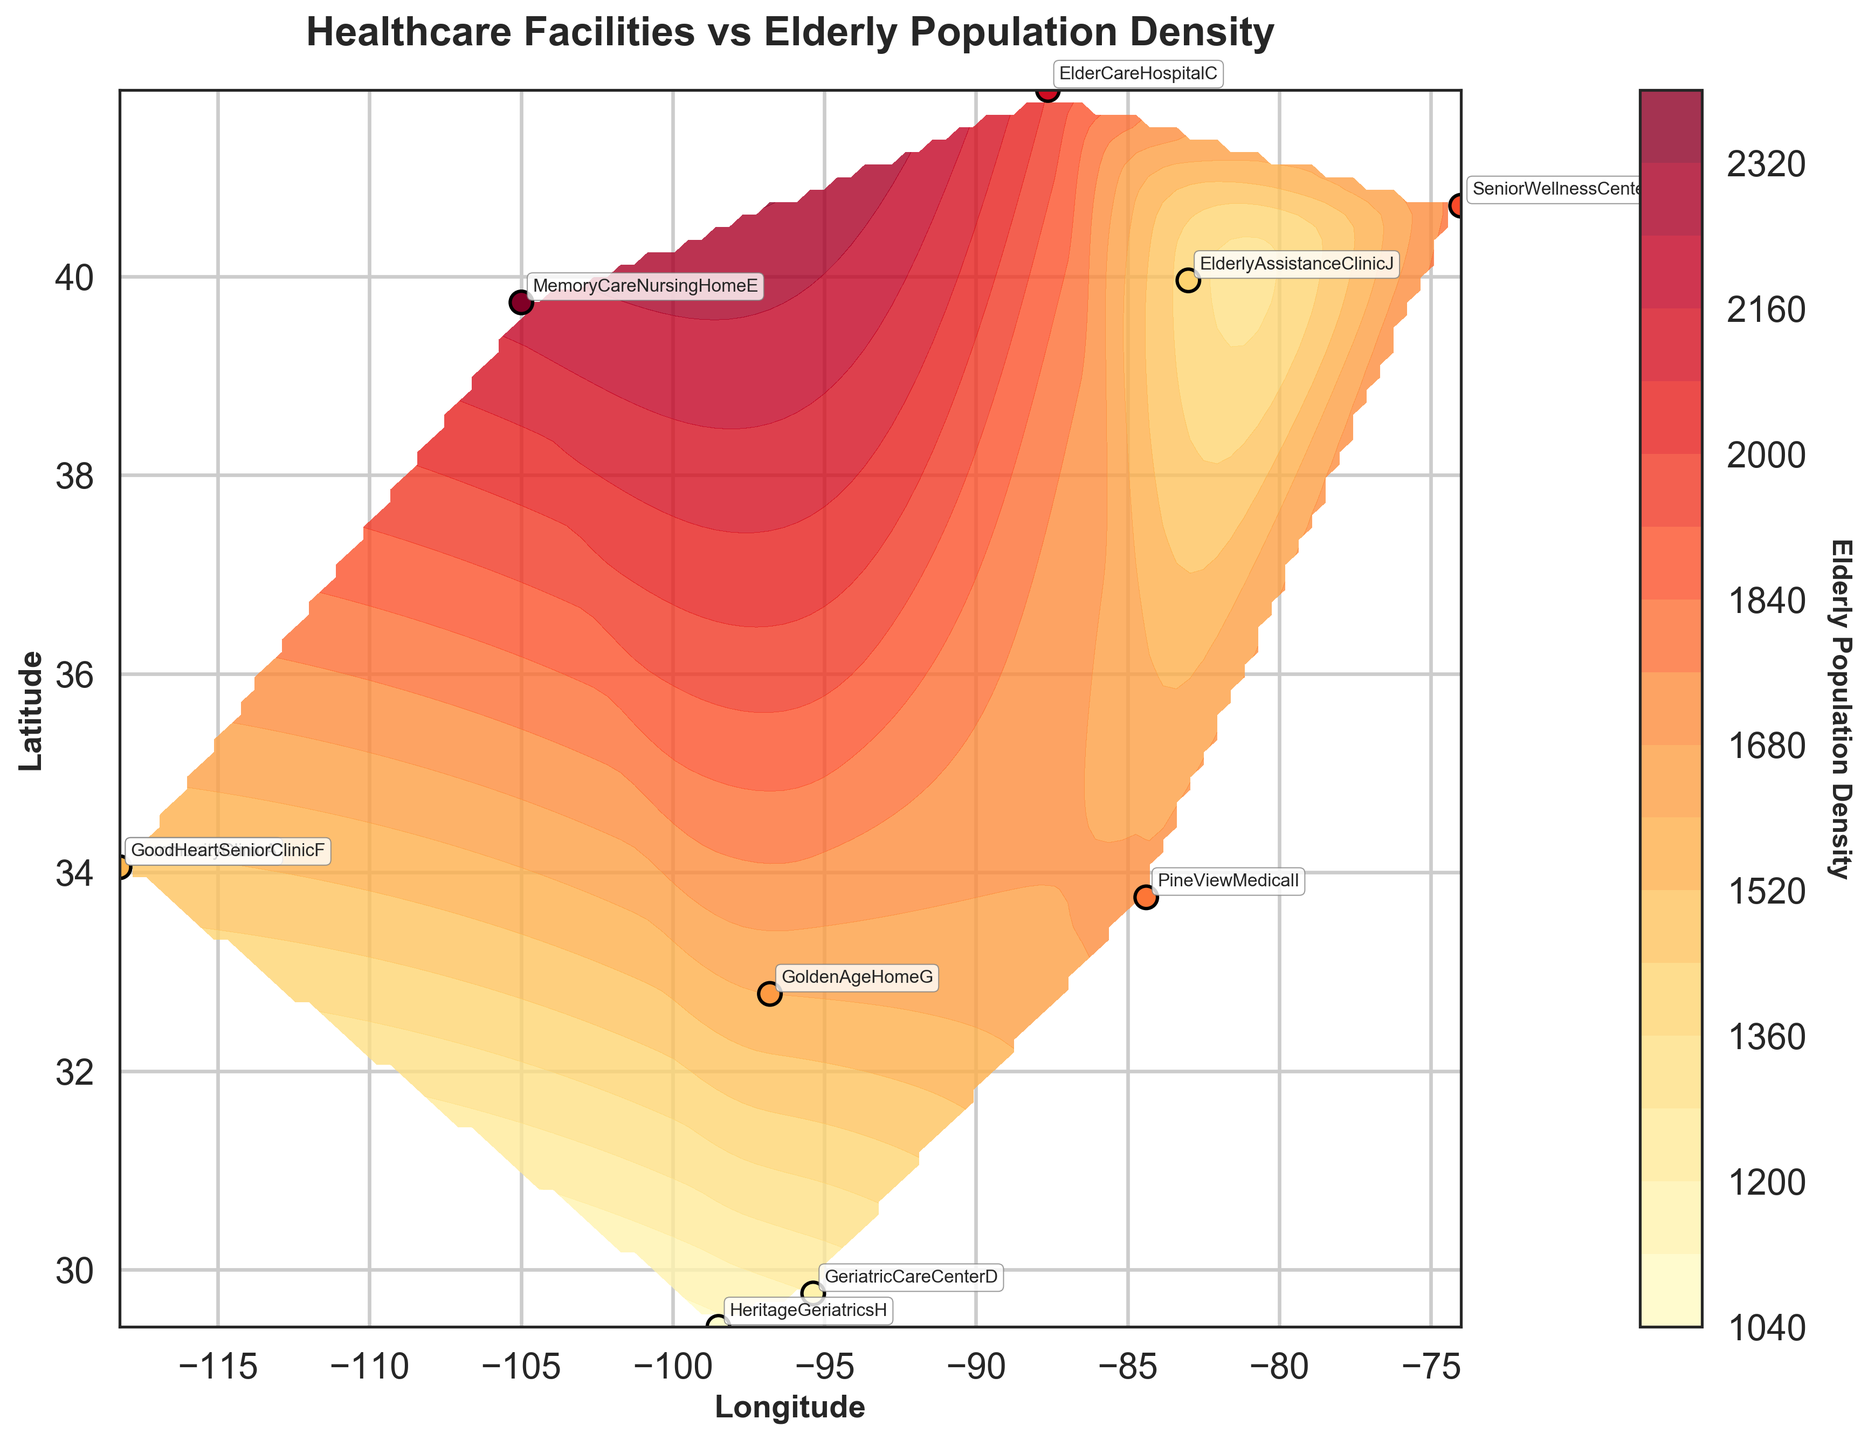What is the title of the plot? The title of a plot is usually found at the top of the figure in bold text. Here, the title reads "Healthcare Facilities vs Elderly Population Density".
Answer: Healthcare Facilities vs Elderly Population Density How many healthcare facilities are shown in the figure? To determine the number of healthcare facilities, look for the distinct labeled points on the plot. There are ten labels corresponding to healthcare facilities.
Answer: 10 Which facility has the highest elderly population density? Identify the facility with the highest color intensity, as the color represents the elderly population density. The facility "MemoryCareNursingHomeE" at the coordinates (39.7392, -104.9903) has the highest value of 2200.
Answer: MemoryCareNursingHomeE Which facility is located at the lowest latitude? Look at the y-axis (latitude) values and identify the facility at the lowest position. "HeritageGeriatricsH" at (29.4241, -98.4936) has the lowest latitude.
Answer: HeritageGeriatricsH Which facilities have the same elderly population density? Look for facilities with identical color intensities. "CommunityClinicA" and "GoodHeartSeniorClinicF" both have a density of 1500, marked by the same color on the plot.
Answer: CommunityClinicA and GoodHeartSeniorClinicF How does the elderly population density at "SeniorWellnessCenterB" compare to "ElderCareHospitalC"? Compare the colors or directly annotated densities of both facilities. "SeniorWellnessCenterB" has a density of 1800, while "ElderCareHospitalC" has 2000. Therefore, "ElderCareHospitalC" has a higher density.
Answer: ElderCareHospitalC is higher What geographical region (longitude and latitude) appears to have the highest elderly population density overall? Look at the contour plot to identify the region with the darkest shade, which indicates the highest density. The region around the coordinates (39.7392, -104.9903) seems to have the highest overall density.
Answer: Around (39.7392, -104.9903) What is the average elderly population density of all healthcare facilities? To find the average, sum all the densities and divide by the number of facilities. Total density = 1500+1800+2000+1200+2200+1500+1600+1100+1700+1400 = 16000. The number of facilities is 10. So, average density = 16000 / 10 = 1600.
Answer: 1600 